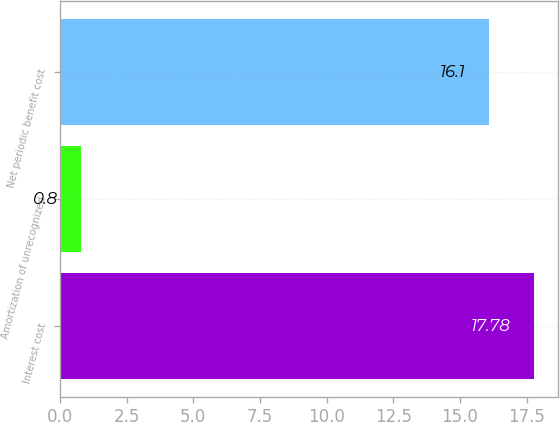Convert chart to OTSL. <chart><loc_0><loc_0><loc_500><loc_500><bar_chart><fcel>Interest cost<fcel>Amortization of unrecognized<fcel>Net periodic benefit cost<nl><fcel>17.78<fcel>0.8<fcel>16.1<nl></chart> 